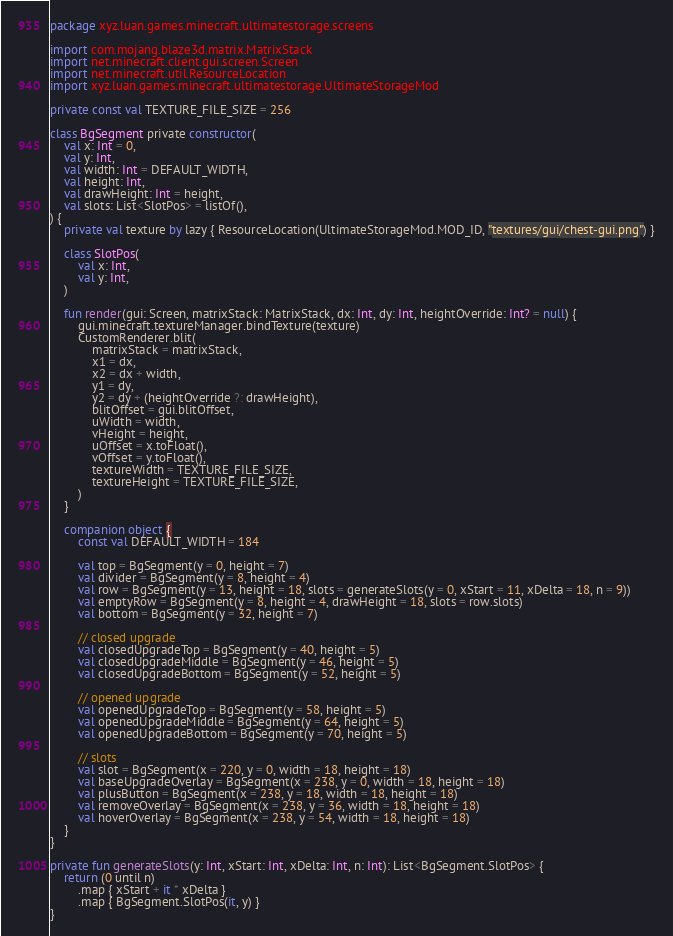Convert code to text. <code><loc_0><loc_0><loc_500><loc_500><_Kotlin_>package xyz.luan.games.minecraft.ultimatestorage.screens

import com.mojang.blaze3d.matrix.MatrixStack
import net.minecraft.client.gui.screen.Screen
import net.minecraft.util.ResourceLocation
import xyz.luan.games.minecraft.ultimatestorage.UltimateStorageMod

private const val TEXTURE_FILE_SIZE = 256

class BgSegment private constructor(
    val x: Int = 0,
    val y: Int,
    val width: Int = DEFAULT_WIDTH,
    val height: Int,
    val drawHeight: Int = height,
    val slots: List<SlotPos> = listOf(),
) {
    private val texture by lazy { ResourceLocation(UltimateStorageMod.MOD_ID, "textures/gui/chest-gui.png") }

    class SlotPos(
        val x: Int,
        val y: Int,
    )

    fun render(gui: Screen, matrixStack: MatrixStack, dx: Int, dy: Int, heightOverride: Int? = null) {
        gui.minecraft.textureManager.bindTexture(texture)
        CustomRenderer.blit(
            matrixStack = matrixStack,
            x1 = dx,
            x2 = dx + width,
            y1 = dy,
            y2 = dy + (heightOverride ?: drawHeight),
            blitOffset = gui.blitOffset,
            uWidth = width,
            vHeight = height,
            uOffset = x.toFloat(),
            vOffset = y.toFloat(),
            textureWidth = TEXTURE_FILE_SIZE,
            textureHeight = TEXTURE_FILE_SIZE,
        )
    }

    companion object {
        const val DEFAULT_WIDTH = 184

        val top = BgSegment(y = 0, height = 7)
        val divider = BgSegment(y = 8, height = 4)
        val row = BgSegment(y = 13, height = 18, slots = generateSlots(y = 0, xStart = 11, xDelta = 18, n = 9))
        val emptyRow = BgSegment(y = 8, height = 4, drawHeight = 18, slots = row.slots)
        val bottom = BgSegment(y = 32, height = 7)

        // closed upgrade
        val closedUpgradeTop = BgSegment(y = 40, height = 5)
        val closedUpgradeMiddle = BgSegment(y = 46, height = 5)
        val closedUpgradeBottom = BgSegment(y = 52, height = 5)

        // opened upgrade
        val openedUpgradeTop = BgSegment(y = 58, height = 5)
        val openedUpgradeMiddle = BgSegment(y = 64, height = 5)
        val openedUpgradeBottom = BgSegment(y = 70, height = 5)

        // slots
        val slot = BgSegment(x = 220, y = 0, width = 18, height = 18)
        val baseUpgradeOverlay = BgSegment(x = 238, y = 0, width = 18, height = 18)
        val plusButton = BgSegment(x = 238, y = 18, width = 18, height = 18)
        val removeOverlay = BgSegment(x = 238, y = 36, width = 18, height = 18)
        val hoverOverlay = BgSegment(x = 238, y = 54, width = 18, height = 18)
    }
}

private fun generateSlots(y: Int, xStart: Int, xDelta: Int, n: Int): List<BgSegment.SlotPos> {
    return (0 until n)
        .map { xStart + it * xDelta }
        .map { BgSegment.SlotPos(it, y) }
}
</code> 